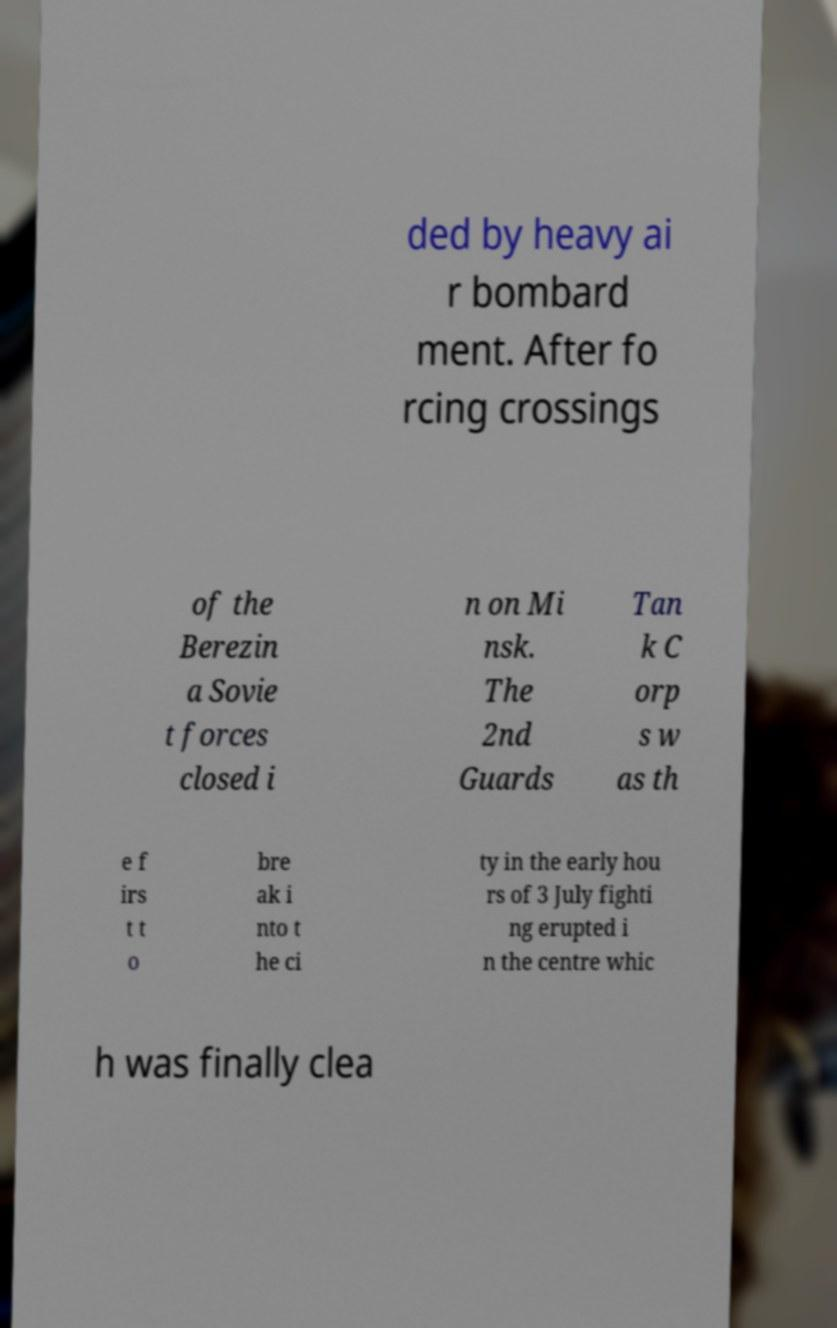Can you read and provide the text displayed in the image?This photo seems to have some interesting text. Can you extract and type it out for me? ded by heavy ai r bombard ment. After fo rcing crossings of the Berezin a Sovie t forces closed i n on Mi nsk. The 2nd Guards Tan k C orp s w as th e f irs t t o bre ak i nto t he ci ty in the early hou rs of 3 July fighti ng erupted i n the centre whic h was finally clea 